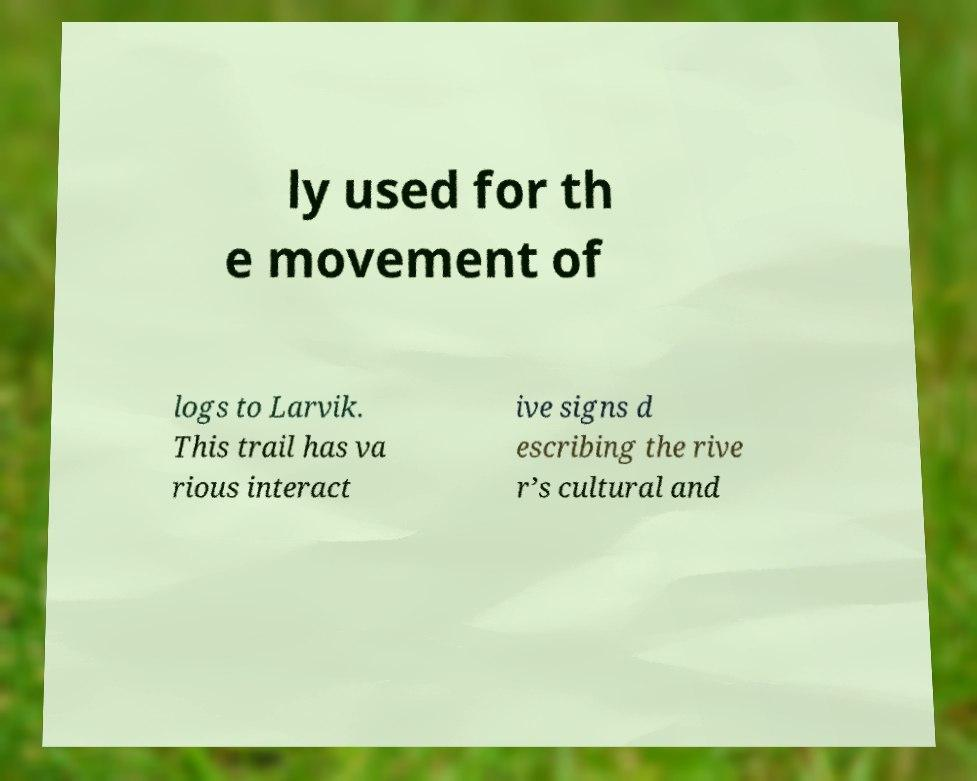Can you read and provide the text displayed in the image?This photo seems to have some interesting text. Can you extract and type it out for me? ly used for th e movement of logs to Larvik. This trail has va rious interact ive signs d escribing the rive r’s cultural and 